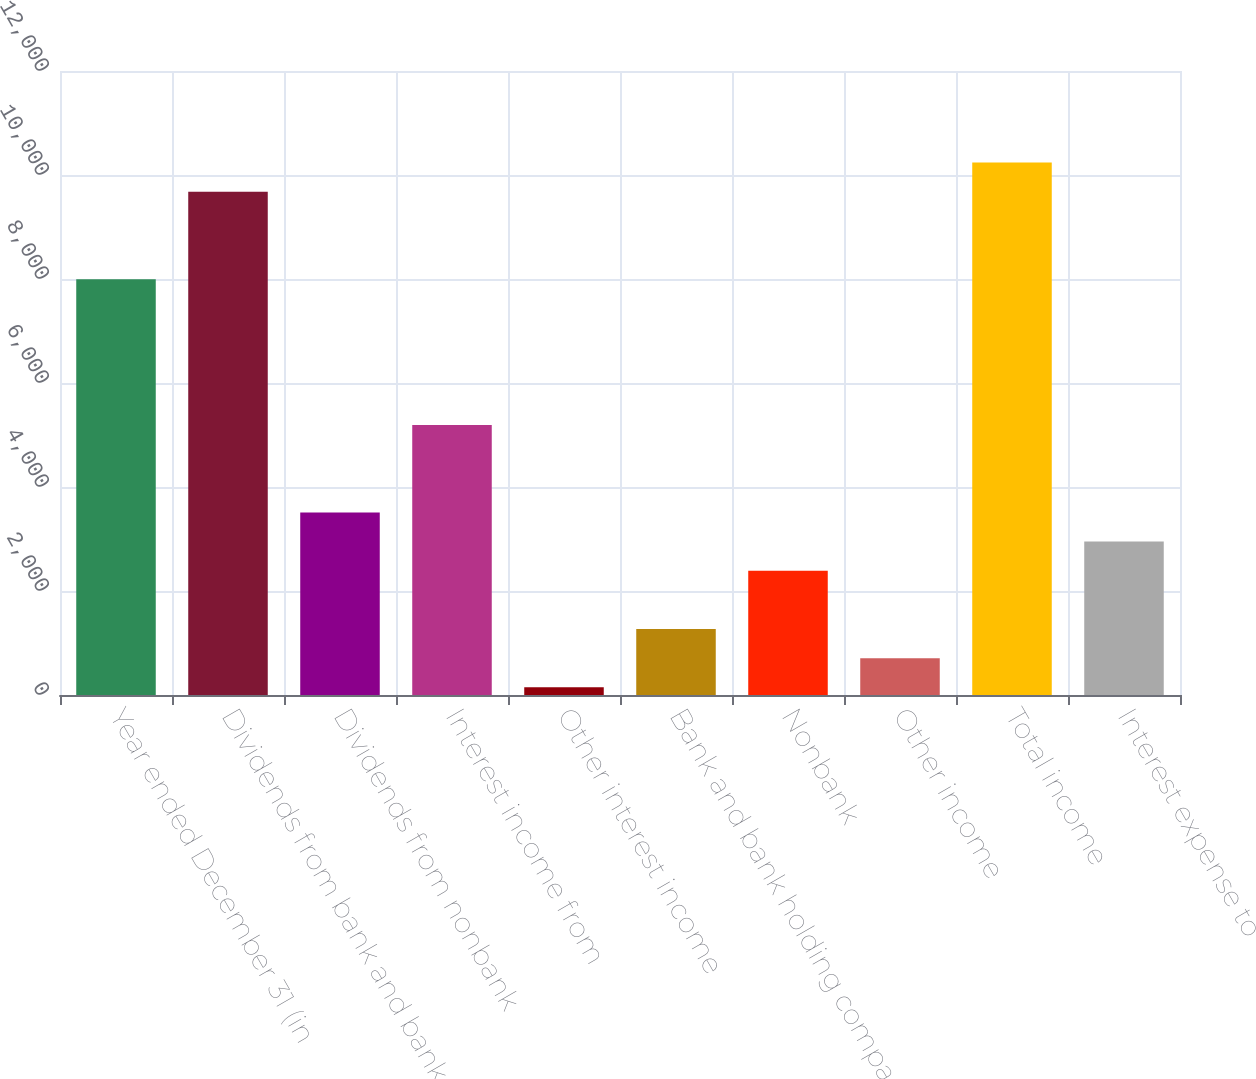<chart> <loc_0><loc_0><loc_500><loc_500><bar_chart><fcel>Year ended December 31 (in<fcel>Dividends from bank and bank<fcel>Dividends from nonbank<fcel>Interest income from<fcel>Other interest income<fcel>Bank and bank holding company<fcel>Nonbank<fcel>Other income<fcel>Total income<fcel>Interest expense to<nl><fcel>7996.4<fcel>9678.2<fcel>3511.6<fcel>5193.4<fcel>148<fcel>1269.2<fcel>2390.4<fcel>708.6<fcel>10238.8<fcel>2951<nl></chart> 